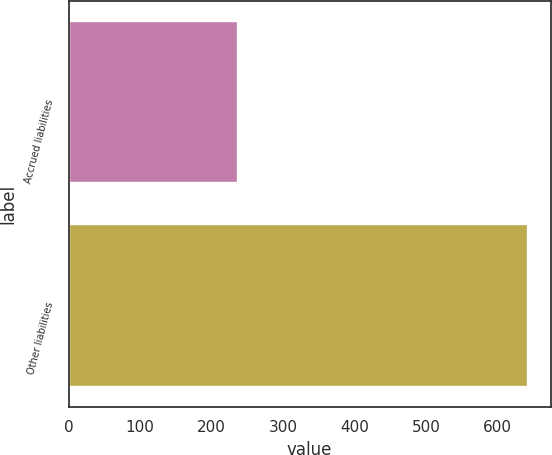Convert chart to OTSL. <chart><loc_0><loc_0><loc_500><loc_500><bar_chart><fcel>Accrued liabilities<fcel>Other liabilities<nl><fcel>237<fcel>642<nl></chart> 